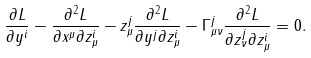<formula> <loc_0><loc_0><loc_500><loc_500>\frac { \partial L } { \partial y ^ { i } } - \frac { \partial ^ { 2 } L } { \partial x ^ { \mu } \partial z ^ { i } _ { \mu } } - z ^ { j } _ { \mu } \frac { \partial ^ { 2 } L } { \partial y ^ { j } \partial z ^ { i } _ { \mu } } - \Gamma ^ { j } _ { \mu \nu } \frac { \partial ^ { 2 } L } { \partial z ^ { j } _ { \nu } \partial z ^ { i } _ { \mu } } = 0 .</formula> 